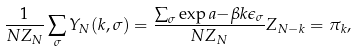<formula> <loc_0><loc_0><loc_500><loc_500>\frac { 1 } { N Z _ { N } } \sum _ { \sigma } Y _ { N } ( k , \sigma ) = \frac { \sum _ { \sigma } \exp a { - \beta k \epsilon _ { \sigma } } } { N Z _ { N } } Z _ { N - k } = \pi _ { k } ,</formula> 